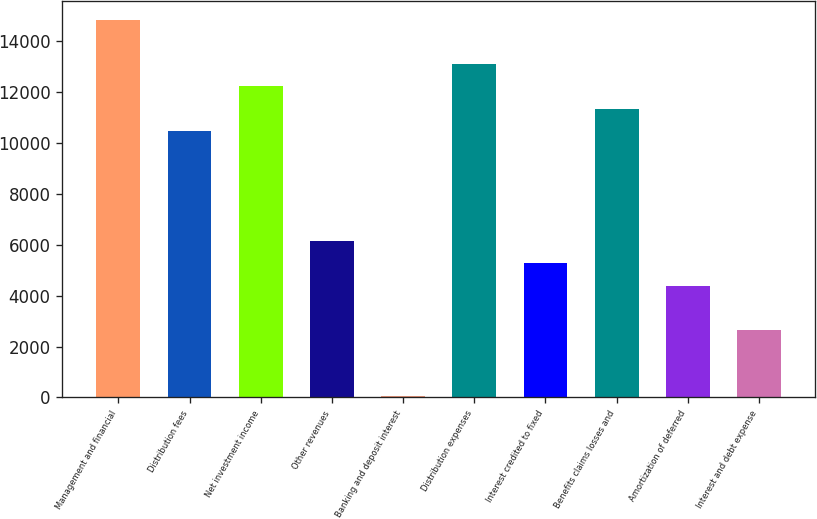<chart> <loc_0><loc_0><loc_500><loc_500><bar_chart><fcel>Management and financial<fcel>Distribution fees<fcel>Net investment income<fcel>Other revenues<fcel>Banking and deposit interest<fcel>Distribution expenses<fcel>Interest credited to fixed<fcel>Benefits claims losses and<fcel>Amortization of deferred<fcel>Interest and debt expense<nl><fcel>14833.6<fcel>10484.6<fcel>12224.2<fcel>6135.6<fcel>47<fcel>13094<fcel>5265.8<fcel>11354.4<fcel>4396<fcel>2656.4<nl></chart> 